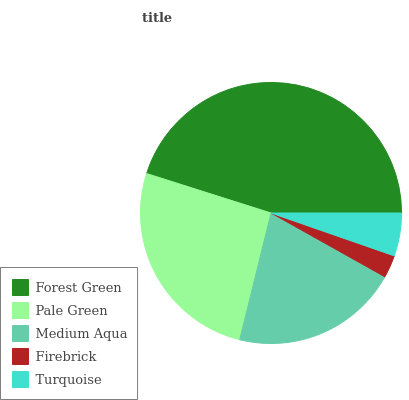Is Firebrick the minimum?
Answer yes or no. Yes. Is Forest Green the maximum?
Answer yes or no. Yes. Is Pale Green the minimum?
Answer yes or no. No. Is Pale Green the maximum?
Answer yes or no. No. Is Forest Green greater than Pale Green?
Answer yes or no. Yes. Is Pale Green less than Forest Green?
Answer yes or no. Yes. Is Pale Green greater than Forest Green?
Answer yes or no. No. Is Forest Green less than Pale Green?
Answer yes or no. No. Is Medium Aqua the high median?
Answer yes or no. Yes. Is Medium Aqua the low median?
Answer yes or no. Yes. Is Forest Green the high median?
Answer yes or no. No. Is Pale Green the low median?
Answer yes or no. No. 